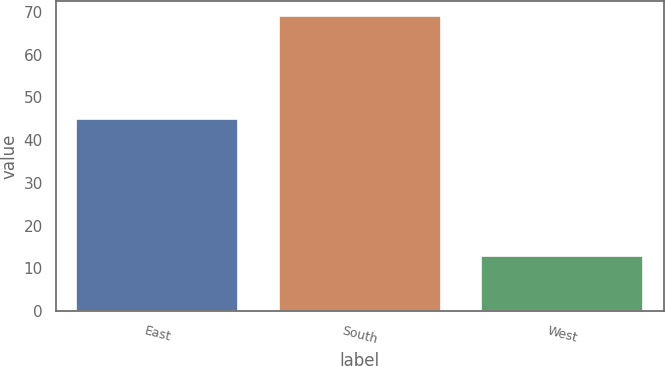Convert chart. <chart><loc_0><loc_0><loc_500><loc_500><bar_chart><fcel>East<fcel>South<fcel>West<nl><fcel>45<fcel>69<fcel>13<nl></chart> 